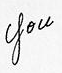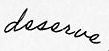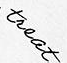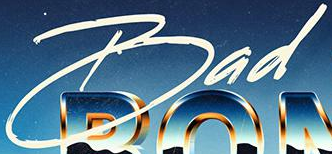What words can you see in these images in sequence, separated by a semicolon? you; deserve; treat; Bad 